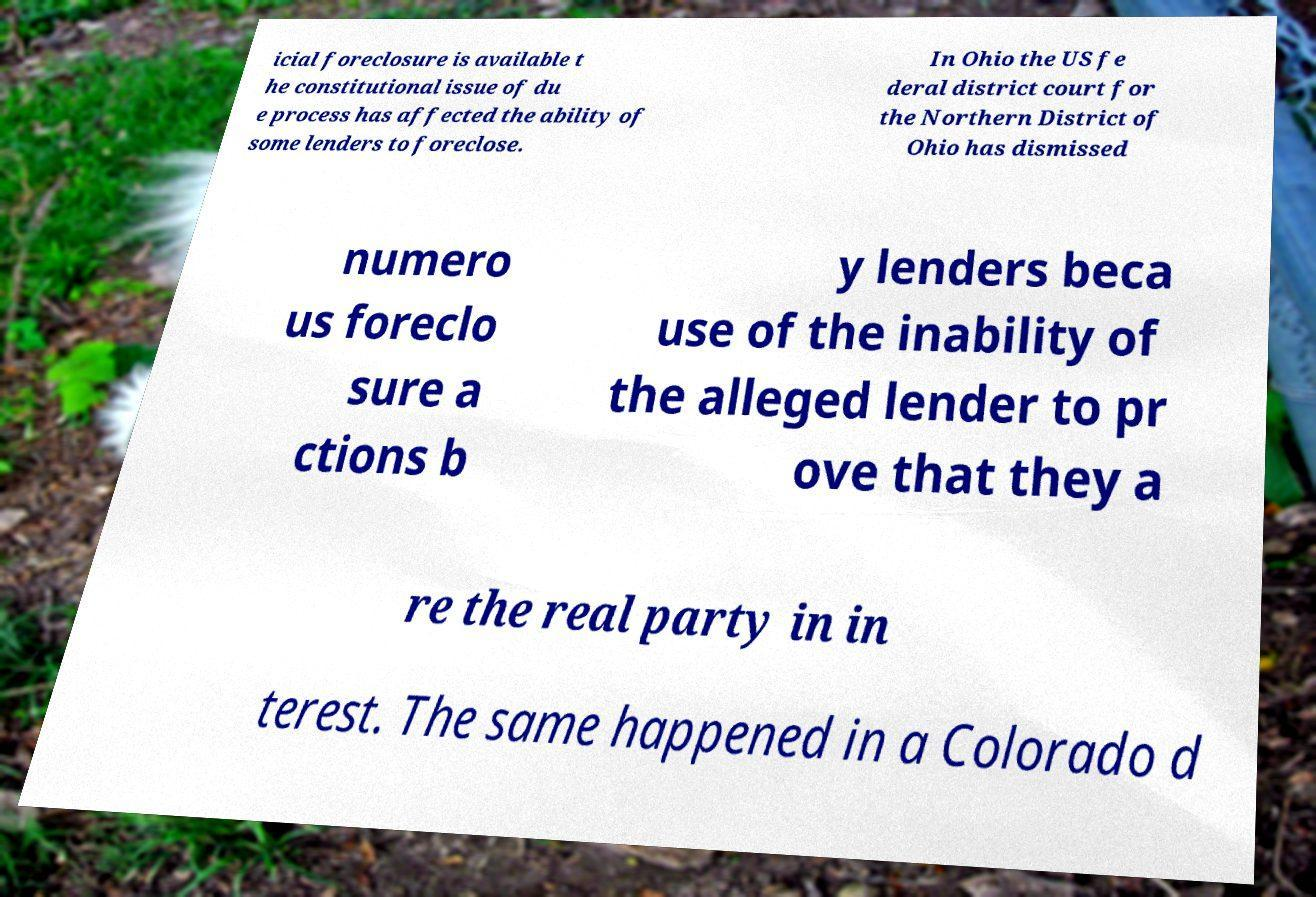There's text embedded in this image that I need extracted. Can you transcribe it verbatim? icial foreclosure is available t he constitutional issue of du e process has affected the ability of some lenders to foreclose. In Ohio the US fe deral district court for the Northern District of Ohio has dismissed numero us foreclo sure a ctions b y lenders beca use of the inability of the alleged lender to pr ove that they a re the real party in in terest. The same happened in a Colorado d 